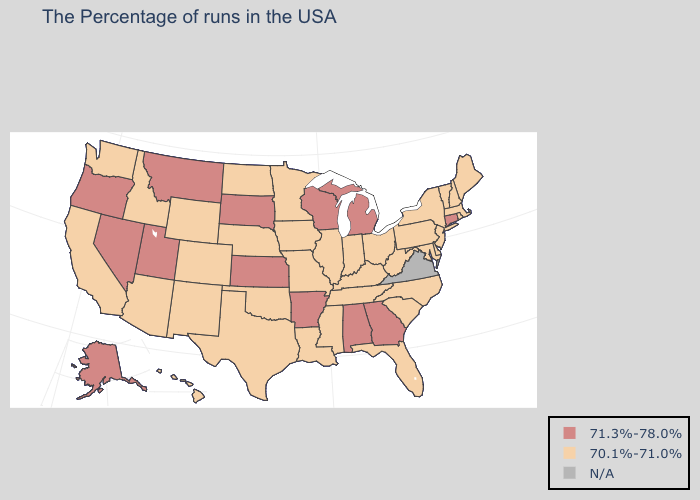Is the legend a continuous bar?
Be succinct. No. What is the value of Florida?
Quick response, please. 70.1%-71.0%. Does the map have missing data?
Give a very brief answer. Yes. Which states have the highest value in the USA?
Answer briefly. Connecticut, Georgia, Michigan, Alabama, Wisconsin, Arkansas, Kansas, South Dakota, Utah, Montana, Nevada, Oregon, Alaska. Name the states that have a value in the range 71.3%-78.0%?
Concise answer only. Connecticut, Georgia, Michigan, Alabama, Wisconsin, Arkansas, Kansas, South Dakota, Utah, Montana, Nevada, Oregon, Alaska. What is the lowest value in states that border Arizona?
Short answer required. 70.1%-71.0%. What is the value of Maryland?
Write a very short answer. 70.1%-71.0%. What is the highest value in the South ?
Concise answer only. 71.3%-78.0%. Which states hav the highest value in the Northeast?
Keep it brief. Connecticut. What is the value of Mississippi?
Concise answer only. 70.1%-71.0%. What is the value of Massachusetts?
Quick response, please. 70.1%-71.0%. What is the highest value in the USA?
Answer briefly. 71.3%-78.0%. Which states hav the highest value in the West?
Be succinct. Utah, Montana, Nevada, Oregon, Alaska. Name the states that have a value in the range 70.1%-71.0%?
Keep it brief. Maine, Massachusetts, Rhode Island, New Hampshire, Vermont, New York, New Jersey, Delaware, Maryland, Pennsylvania, North Carolina, South Carolina, West Virginia, Ohio, Florida, Kentucky, Indiana, Tennessee, Illinois, Mississippi, Louisiana, Missouri, Minnesota, Iowa, Nebraska, Oklahoma, Texas, North Dakota, Wyoming, Colorado, New Mexico, Arizona, Idaho, California, Washington, Hawaii. How many symbols are there in the legend?
Concise answer only. 3. 